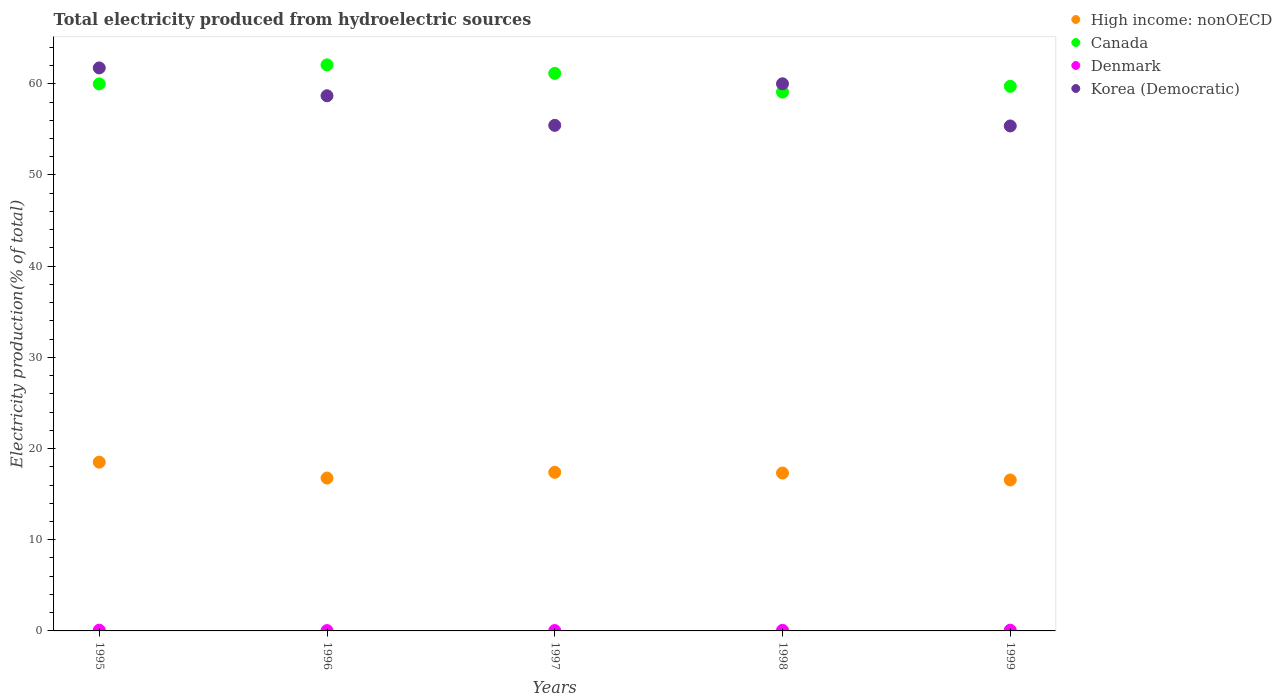Is the number of dotlines equal to the number of legend labels?
Provide a short and direct response. Yes. What is the total electricity produced in High income: nonOECD in 1998?
Your response must be concise. 17.31. Across all years, what is the maximum total electricity produced in High income: nonOECD?
Ensure brevity in your answer.  18.5. Across all years, what is the minimum total electricity produced in Canada?
Ensure brevity in your answer.  59.09. In which year was the total electricity produced in Canada minimum?
Ensure brevity in your answer.  1998. What is the total total electricity produced in Canada in the graph?
Make the answer very short. 302.02. What is the difference between the total electricity produced in High income: nonOECD in 1995 and that in 1996?
Keep it short and to the point. 1.74. What is the difference between the total electricity produced in Denmark in 1998 and the total electricity produced in Korea (Democratic) in 1999?
Offer a terse response. -55.31. What is the average total electricity produced in Denmark per year?
Give a very brief answer. 0.06. In the year 1999, what is the difference between the total electricity produced in High income: nonOECD and total electricity produced in Denmark?
Provide a short and direct response. 16.47. What is the ratio of the total electricity produced in Korea (Democratic) in 1995 to that in 1996?
Offer a very short reply. 1.05. Is the total electricity produced in High income: nonOECD in 1995 less than that in 1998?
Your response must be concise. No. Is the difference between the total electricity produced in High income: nonOECD in 1997 and 1998 greater than the difference between the total electricity produced in Denmark in 1997 and 1998?
Your answer should be very brief. Yes. What is the difference between the highest and the second highest total electricity produced in Denmark?
Offer a terse response. 0. What is the difference between the highest and the lowest total electricity produced in Canada?
Your answer should be very brief. 2.98. Is the sum of the total electricity produced in High income: nonOECD in 1996 and 1998 greater than the maximum total electricity produced in Denmark across all years?
Provide a succinct answer. Yes. Is it the case that in every year, the sum of the total electricity produced in Korea (Democratic) and total electricity produced in High income: nonOECD  is greater than the total electricity produced in Canada?
Your answer should be very brief. Yes. How many dotlines are there?
Keep it short and to the point. 4. How many years are there in the graph?
Give a very brief answer. 5. Are the values on the major ticks of Y-axis written in scientific E-notation?
Offer a very short reply. No. Does the graph contain grids?
Provide a short and direct response. No. Where does the legend appear in the graph?
Your answer should be compact. Top right. How are the legend labels stacked?
Offer a terse response. Vertical. What is the title of the graph?
Your answer should be very brief. Total electricity produced from hydroelectric sources. Does "Kuwait" appear as one of the legend labels in the graph?
Provide a short and direct response. No. What is the label or title of the X-axis?
Provide a short and direct response. Years. What is the Electricity production(% of total) in High income: nonOECD in 1995?
Provide a succinct answer. 18.5. What is the Electricity production(% of total) of Canada in 1995?
Offer a terse response. 59.99. What is the Electricity production(% of total) of Denmark in 1995?
Keep it short and to the point. 0.08. What is the Electricity production(% of total) in Korea (Democratic) in 1995?
Your response must be concise. 61.74. What is the Electricity production(% of total) of High income: nonOECD in 1996?
Your answer should be very brief. 16.76. What is the Electricity production(% of total) in Canada in 1996?
Offer a very short reply. 62.08. What is the Electricity production(% of total) in Denmark in 1996?
Provide a short and direct response. 0.04. What is the Electricity production(% of total) of Korea (Democratic) in 1996?
Give a very brief answer. 58.69. What is the Electricity production(% of total) of High income: nonOECD in 1997?
Keep it short and to the point. 17.39. What is the Electricity production(% of total) of Canada in 1997?
Offer a terse response. 61.14. What is the Electricity production(% of total) in Denmark in 1997?
Provide a short and direct response. 0.04. What is the Electricity production(% of total) of Korea (Democratic) in 1997?
Provide a short and direct response. 55.44. What is the Electricity production(% of total) of High income: nonOECD in 1998?
Keep it short and to the point. 17.31. What is the Electricity production(% of total) of Canada in 1998?
Your response must be concise. 59.09. What is the Electricity production(% of total) of Denmark in 1998?
Give a very brief answer. 0.07. What is the Electricity production(% of total) in High income: nonOECD in 1999?
Make the answer very short. 16.55. What is the Electricity production(% of total) in Canada in 1999?
Your response must be concise. 59.72. What is the Electricity production(% of total) of Denmark in 1999?
Provide a short and direct response. 0.08. What is the Electricity production(% of total) in Korea (Democratic) in 1999?
Provide a short and direct response. 55.38. Across all years, what is the maximum Electricity production(% of total) in High income: nonOECD?
Keep it short and to the point. 18.5. Across all years, what is the maximum Electricity production(% of total) in Canada?
Keep it short and to the point. 62.08. Across all years, what is the maximum Electricity production(% of total) in Denmark?
Provide a short and direct response. 0.08. Across all years, what is the maximum Electricity production(% of total) in Korea (Democratic)?
Offer a terse response. 61.74. Across all years, what is the minimum Electricity production(% of total) in High income: nonOECD?
Give a very brief answer. 16.55. Across all years, what is the minimum Electricity production(% of total) in Canada?
Your response must be concise. 59.09. Across all years, what is the minimum Electricity production(% of total) of Denmark?
Keep it short and to the point. 0.04. Across all years, what is the minimum Electricity production(% of total) of Korea (Democratic)?
Keep it short and to the point. 55.38. What is the total Electricity production(% of total) of High income: nonOECD in the graph?
Ensure brevity in your answer.  86.53. What is the total Electricity production(% of total) of Canada in the graph?
Your answer should be compact. 302.02. What is the total Electricity production(% of total) in Denmark in the graph?
Offer a terse response. 0.31. What is the total Electricity production(% of total) of Korea (Democratic) in the graph?
Make the answer very short. 291.24. What is the difference between the Electricity production(% of total) in High income: nonOECD in 1995 and that in 1996?
Provide a short and direct response. 1.74. What is the difference between the Electricity production(% of total) of Canada in 1995 and that in 1996?
Provide a succinct answer. -2.09. What is the difference between the Electricity production(% of total) in Denmark in 1995 and that in 1996?
Your answer should be compact. 0.05. What is the difference between the Electricity production(% of total) of Korea (Democratic) in 1995 and that in 1996?
Ensure brevity in your answer.  3.05. What is the difference between the Electricity production(% of total) in High income: nonOECD in 1995 and that in 1997?
Provide a succinct answer. 1.11. What is the difference between the Electricity production(% of total) of Canada in 1995 and that in 1997?
Keep it short and to the point. -1.15. What is the difference between the Electricity production(% of total) of Denmark in 1995 and that in 1997?
Keep it short and to the point. 0.04. What is the difference between the Electricity production(% of total) of Korea (Democratic) in 1995 and that in 1997?
Keep it short and to the point. 6.3. What is the difference between the Electricity production(% of total) of High income: nonOECD in 1995 and that in 1998?
Provide a succinct answer. 1.19. What is the difference between the Electricity production(% of total) in Canada in 1995 and that in 1998?
Ensure brevity in your answer.  0.89. What is the difference between the Electricity production(% of total) in Denmark in 1995 and that in 1998?
Your answer should be very brief. 0.02. What is the difference between the Electricity production(% of total) in Korea (Democratic) in 1995 and that in 1998?
Your response must be concise. 1.74. What is the difference between the Electricity production(% of total) in High income: nonOECD in 1995 and that in 1999?
Make the answer very short. 1.95. What is the difference between the Electricity production(% of total) of Canada in 1995 and that in 1999?
Provide a short and direct response. 0.26. What is the difference between the Electricity production(% of total) of Denmark in 1995 and that in 1999?
Make the answer very short. 0. What is the difference between the Electricity production(% of total) of Korea (Democratic) in 1995 and that in 1999?
Provide a succinct answer. 6.36. What is the difference between the Electricity production(% of total) of High income: nonOECD in 1996 and that in 1997?
Make the answer very short. -0.63. What is the difference between the Electricity production(% of total) of Canada in 1996 and that in 1997?
Your answer should be very brief. 0.94. What is the difference between the Electricity production(% of total) in Denmark in 1996 and that in 1997?
Ensure brevity in your answer.  -0.01. What is the difference between the Electricity production(% of total) in Korea (Democratic) in 1996 and that in 1997?
Your answer should be compact. 3.25. What is the difference between the Electricity production(% of total) in High income: nonOECD in 1996 and that in 1998?
Offer a terse response. -0.55. What is the difference between the Electricity production(% of total) in Canada in 1996 and that in 1998?
Give a very brief answer. 2.98. What is the difference between the Electricity production(% of total) of Denmark in 1996 and that in 1998?
Make the answer very short. -0.03. What is the difference between the Electricity production(% of total) in Korea (Democratic) in 1996 and that in 1998?
Give a very brief answer. -1.31. What is the difference between the Electricity production(% of total) in High income: nonOECD in 1996 and that in 1999?
Ensure brevity in your answer.  0.21. What is the difference between the Electricity production(% of total) of Canada in 1996 and that in 1999?
Your response must be concise. 2.35. What is the difference between the Electricity production(% of total) in Denmark in 1996 and that in 1999?
Keep it short and to the point. -0.04. What is the difference between the Electricity production(% of total) of Korea (Democratic) in 1996 and that in 1999?
Your answer should be compact. 3.31. What is the difference between the Electricity production(% of total) of High income: nonOECD in 1997 and that in 1998?
Provide a short and direct response. 0.08. What is the difference between the Electricity production(% of total) of Canada in 1997 and that in 1998?
Provide a succinct answer. 2.05. What is the difference between the Electricity production(% of total) of Denmark in 1997 and that in 1998?
Make the answer very short. -0.02. What is the difference between the Electricity production(% of total) of Korea (Democratic) in 1997 and that in 1998?
Provide a short and direct response. -4.56. What is the difference between the Electricity production(% of total) of High income: nonOECD in 1997 and that in 1999?
Keep it short and to the point. 0.84. What is the difference between the Electricity production(% of total) in Canada in 1997 and that in 1999?
Keep it short and to the point. 1.42. What is the difference between the Electricity production(% of total) of Denmark in 1997 and that in 1999?
Provide a short and direct response. -0.04. What is the difference between the Electricity production(% of total) in Korea (Democratic) in 1997 and that in 1999?
Your answer should be compact. 0.06. What is the difference between the Electricity production(% of total) in High income: nonOECD in 1998 and that in 1999?
Make the answer very short. 0.76. What is the difference between the Electricity production(% of total) of Canada in 1998 and that in 1999?
Keep it short and to the point. -0.63. What is the difference between the Electricity production(% of total) in Denmark in 1998 and that in 1999?
Provide a succinct answer. -0.01. What is the difference between the Electricity production(% of total) in Korea (Democratic) in 1998 and that in 1999?
Make the answer very short. 4.62. What is the difference between the Electricity production(% of total) of High income: nonOECD in 1995 and the Electricity production(% of total) of Canada in 1996?
Your answer should be very brief. -43.57. What is the difference between the Electricity production(% of total) of High income: nonOECD in 1995 and the Electricity production(% of total) of Denmark in 1996?
Keep it short and to the point. 18.47. What is the difference between the Electricity production(% of total) in High income: nonOECD in 1995 and the Electricity production(% of total) in Korea (Democratic) in 1996?
Your answer should be very brief. -40.18. What is the difference between the Electricity production(% of total) of Canada in 1995 and the Electricity production(% of total) of Denmark in 1996?
Provide a succinct answer. 59.95. What is the difference between the Electricity production(% of total) of Canada in 1995 and the Electricity production(% of total) of Korea (Democratic) in 1996?
Your answer should be very brief. 1.3. What is the difference between the Electricity production(% of total) in Denmark in 1995 and the Electricity production(% of total) in Korea (Democratic) in 1996?
Your response must be concise. -58.6. What is the difference between the Electricity production(% of total) in High income: nonOECD in 1995 and the Electricity production(% of total) in Canada in 1997?
Your response must be concise. -42.64. What is the difference between the Electricity production(% of total) in High income: nonOECD in 1995 and the Electricity production(% of total) in Denmark in 1997?
Give a very brief answer. 18.46. What is the difference between the Electricity production(% of total) in High income: nonOECD in 1995 and the Electricity production(% of total) in Korea (Democratic) in 1997?
Your response must be concise. -36.94. What is the difference between the Electricity production(% of total) of Canada in 1995 and the Electricity production(% of total) of Denmark in 1997?
Ensure brevity in your answer.  59.94. What is the difference between the Electricity production(% of total) in Canada in 1995 and the Electricity production(% of total) in Korea (Democratic) in 1997?
Your response must be concise. 4.55. What is the difference between the Electricity production(% of total) in Denmark in 1995 and the Electricity production(% of total) in Korea (Democratic) in 1997?
Offer a very short reply. -55.36. What is the difference between the Electricity production(% of total) in High income: nonOECD in 1995 and the Electricity production(% of total) in Canada in 1998?
Offer a terse response. -40.59. What is the difference between the Electricity production(% of total) of High income: nonOECD in 1995 and the Electricity production(% of total) of Denmark in 1998?
Offer a very short reply. 18.44. What is the difference between the Electricity production(% of total) in High income: nonOECD in 1995 and the Electricity production(% of total) in Korea (Democratic) in 1998?
Ensure brevity in your answer.  -41.5. What is the difference between the Electricity production(% of total) in Canada in 1995 and the Electricity production(% of total) in Denmark in 1998?
Offer a terse response. 59.92. What is the difference between the Electricity production(% of total) of Canada in 1995 and the Electricity production(% of total) of Korea (Democratic) in 1998?
Your response must be concise. -0.01. What is the difference between the Electricity production(% of total) of Denmark in 1995 and the Electricity production(% of total) of Korea (Democratic) in 1998?
Ensure brevity in your answer.  -59.92. What is the difference between the Electricity production(% of total) in High income: nonOECD in 1995 and the Electricity production(% of total) in Canada in 1999?
Keep it short and to the point. -41.22. What is the difference between the Electricity production(% of total) of High income: nonOECD in 1995 and the Electricity production(% of total) of Denmark in 1999?
Offer a terse response. 18.42. What is the difference between the Electricity production(% of total) in High income: nonOECD in 1995 and the Electricity production(% of total) in Korea (Democratic) in 1999?
Offer a terse response. -36.87. What is the difference between the Electricity production(% of total) in Canada in 1995 and the Electricity production(% of total) in Denmark in 1999?
Keep it short and to the point. 59.91. What is the difference between the Electricity production(% of total) in Canada in 1995 and the Electricity production(% of total) in Korea (Democratic) in 1999?
Offer a very short reply. 4.61. What is the difference between the Electricity production(% of total) in Denmark in 1995 and the Electricity production(% of total) in Korea (Democratic) in 1999?
Your answer should be compact. -55.29. What is the difference between the Electricity production(% of total) of High income: nonOECD in 1996 and the Electricity production(% of total) of Canada in 1997?
Ensure brevity in your answer.  -44.38. What is the difference between the Electricity production(% of total) of High income: nonOECD in 1996 and the Electricity production(% of total) of Denmark in 1997?
Offer a terse response. 16.72. What is the difference between the Electricity production(% of total) of High income: nonOECD in 1996 and the Electricity production(% of total) of Korea (Democratic) in 1997?
Give a very brief answer. -38.68. What is the difference between the Electricity production(% of total) in Canada in 1996 and the Electricity production(% of total) in Denmark in 1997?
Offer a terse response. 62.03. What is the difference between the Electricity production(% of total) in Canada in 1996 and the Electricity production(% of total) in Korea (Democratic) in 1997?
Your response must be concise. 6.63. What is the difference between the Electricity production(% of total) of Denmark in 1996 and the Electricity production(% of total) of Korea (Democratic) in 1997?
Offer a very short reply. -55.41. What is the difference between the Electricity production(% of total) in High income: nonOECD in 1996 and the Electricity production(% of total) in Canada in 1998?
Your answer should be very brief. -42.33. What is the difference between the Electricity production(% of total) in High income: nonOECD in 1996 and the Electricity production(% of total) in Denmark in 1998?
Give a very brief answer. 16.7. What is the difference between the Electricity production(% of total) in High income: nonOECD in 1996 and the Electricity production(% of total) in Korea (Democratic) in 1998?
Ensure brevity in your answer.  -43.24. What is the difference between the Electricity production(% of total) of Canada in 1996 and the Electricity production(% of total) of Denmark in 1998?
Your response must be concise. 62.01. What is the difference between the Electricity production(% of total) in Canada in 1996 and the Electricity production(% of total) in Korea (Democratic) in 1998?
Your answer should be compact. 2.08. What is the difference between the Electricity production(% of total) of Denmark in 1996 and the Electricity production(% of total) of Korea (Democratic) in 1998?
Provide a short and direct response. -59.96. What is the difference between the Electricity production(% of total) in High income: nonOECD in 1996 and the Electricity production(% of total) in Canada in 1999?
Make the answer very short. -42.96. What is the difference between the Electricity production(% of total) in High income: nonOECD in 1996 and the Electricity production(% of total) in Denmark in 1999?
Offer a very short reply. 16.68. What is the difference between the Electricity production(% of total) of High income: nonOECD in 1996 and the Electricity production(% of total) of Korea (Democratic) in 1999?
Make the answer very short. -38.61. What is the difference between the Electricity production(% of total) in Canada in 1996 and the Electricity production(% of total) in Denmark in 1999?
Your response must be concise. 62. What is the difference between the Electricity production(% of total) of Canada in 1996 and the Electricity production(% of total) of Korea (Democratic) in 1999?
Offer a very short reply. 6.7. What is the difference between the Electricity production(% of total) of Denmark in 1996 and the Electricity production(% of total) of Korea (Democratic) in 1999?
Offer a very short reply. -55.34. What is the difference between the Electricity production(% of total) in High income: nonOECD in 1997 and the Electricity production(% of total) in Canada in 1998?
Give a very brief answer. -41.7. What is the difference between the Electricity production(% of total) in High income: nonOECD in 1997 and the Electricity production(% of total) in Denmark in 1998?
Keep it short and to the point. 17.33. What is the difference between the Electricity production(% of total) of High income: nonOECD in 1997 and the Electricity production(% of total) of Korea (Democratic) in 1998?
Keep it short and to the point. -42.61. What is the difference between the Electricity production(% of total) of Canada in 1997 and the Electricity production(% of total) of Denmark in 1998?
Make the answer very short. 61.07. What is the difference between the Electricity production(% of total) of Canada in 1997 and the Electricity production(% of total) of Korea (Democratic) in 1998?
Give a very brief answer. 1.14. What is the difference between the Electricity production(% of total) in Denmark in 1997 and the Electricity production(% of total) in Korea (Democratic) in 1998?
Ensure brevity in your answer.  -59.96. What is the difference between the Electricity production(% of total) in High income: nonOECD in 1997 and the Electricity production(% of total) in Canada in 1999?
Your answer should be compact. -42.33. What is the difference between the Electricity production(% of total) in High income: nonOECD in 1997 and the Electricity production(% of total) in Denmark in 1999?
Offer a terse response. 17.31. What is the difference between the Electricity production(% of total) in High income: nonOECD in 1997 and the Electricity production(% of total) in Korea (Democratic) in 1999?
Make the answer very short. -37.98. What is the difference between the Electricity production(% of total) in Canada in 1997 and the Electricity production(% of total) in Denmark in 1999?
Your response must be concise. 61.06. What is the difference between the Electricity production(% of total) of Canada in 1997 and the Electricity production(% of total) of Korea (Democratic) in 1999?
Provide a short and direct response. 5.76. What is the difference between the Electricity production(% of total) of Denmark in 1997 and the Electricity production(% of total) of Korea (Democratic) in 1999?
Give a very brief answer. -55.33. What is the difference between the Electricity production(% of total) of High income: nonOECD in 1998 and the Electricity production(% of total) of Canada in 1999?
Keep it short and to the point. -42.41. What is the difference between the Electricity production(% of total) in High income: nonOECD in 1998 and the Electricity production(% of total) in Denmark in 1999?
Your answer should be very brief. 17.23. What is the difference between the Electricity production(% of total) in High income: nonOECD in 1998 and the Electricity production(% of total) in Korea (Democratic) in 1999?
Give a very brief answer. -38.06. What is the difference between the Electricity production(% of total) of Canada in 1998 and the Electricity production(% of total) of Denmark in 1999?
Ensure brevity in your answer.  59.01. What is the difference between the Electricity production(% of total) in Canada in 1998 and the Electricity production(% of total) in Korea (Democratic) in 1999?
Offer a very short reply. 3.72. What is the difference between the Electricity production(% of total) in Denmark in 1998 and the Electricity production(% of total) in Korea (Democratic) in 1999?
Provide a short and direct response. -55.31. What is the average Electricity production(% of total) in High income: nonOECD per year?
Provide a succinct answer. 17.31. What is the average Electricity production(% of total) of Canada per year?
Keep it short and to the point. 60.4. What is the average Electricity production(% of total) of Denmark per year?
Offer a terse response. 0.06. What is the average Electricity production(% of total) in Korea (Democratic) per year?
Your response must be concise. 58.25. In the year 1995, what is the difference between the Electricity production(% of total) of High income: nonOECD and Electricity production(% of total) of Canada?
Offer a terse response. -41.48. In the year 1995, what is the difference between the Electricity production(% of total) of High income: nonOECD and Electricity production(% of total) of Denmark?
Give a very brief answer. 18.42. In the year 1995, what is the difference between the Electricity production(% of total) in High income: nonOECD and Electricity production(% of total) in Korea (Democratic)?
Offer a terse response. -43.24. In the year 1995, what is the difference between the Electricity production(% of total) of Canada and Electricity production(% of total) of Denmark?
Ensure brevity in your answer.  59.9. In the year 1995, what is the difference between the Electricity production(% of total) in Canada and Electricity production(% of total) in Korea (Democratic)?
Your answer should be very brief. -1.75. In the year 1995, what is the difference between the Electricity production(% of total) in Denmark and Electricity production(% of total) in Korea (Democratic)?
Your response must be concise. -61.66. In the year 1996, what is the difference between the Electricity production(% of total) in High income: nonOECD and Electricity production(% of total) in Canada?
Your answer should be very brief. -45.31. In the year 1996, what is the difference between the Electricity production(% of total) in High income: nonOECD and Electricity production(% of total) in Denmark?
Provide a succinct answer. 16.73. In the year 1996, what is the difference between the Electricity production(% of total) in High income: nonOECD and Electricity production(% of total) in Korea (Democratic)?
Keep it short and to the point. -41.92. In the year 1996, what is the difference between the Electricity production(% of total) in Canada and Electricity production(% of total) in Denmark?
Offer a terse response. 62.04. In the year 1996, what is the difference between the Electricity production(% of total) of Canada and Electricity production(% of total) of Korea (Democratic)?
Your answer should be compact. 3.39. In the year 1996, what is the difference between the Electricity production(% of total) in Denmark and Electricity production(% of total) in Korea (Democratic)?
Your answer should be very brief. -58.65. In the year 1997, what is the difference between the Electricity production(% of total) of High income: nonOECD and Electricity production(% of total) of Canada?
Provide a succinct answer. -43.75. In the year 1997, what is the difference between the Electricity production(% of total) of High income: nonOECD and Electricity production(% of total) of Denmark?
Provide a succinct answer. 17.35. In the year 1997, what is the difference between the Electricity production(% of total) in High income: nonOECD and Electricity production(% of total) in Korea (Democratic)?
Ensure brevity in your answer.  -38.05. In the year 1997, what is the difference between the Electricity production(% of total) in Canada and Electricity production(% of total) in Denmark?
Keep it short and to the point. 61.1. In the year 1997, what is the difference between the Electricity production(% of total) in Canada and Electricity production(% of total) in Korea (Democratic)?
Provide a short and direct response. 5.7. In the year 1997, what is the difference between the Electricity production(% of total) in Denmark and Electricity production(% of total) in Korea (Democratic)?
Your answer should be very brief. -55.4. In the year 1998, what is the difference between the Electricity production(% of total) in High income: nonOECD and Electricity production(% of total) in Canada?
Your answer should be compact. -41.78. In the year 1998, what is the difference between the Electricity production(% of total) of High income: nonOECD and Electricity production(% of total) of Denmark?
Keep it short and to the point. 17.25. In the year 1998, what is the difference between the Electricity production(% of total) of High income: nonOECD and Electricity production(% of total) of Korea (Democratic)?
Your response must be concise. -42.69. In the year 1998, what is the difference between the Electricity production(% of total) of Canada and Electricity production(% of total) of Denmark?
Offer a terse response. 59.03. In the year 1998, what is the difference between the Electricity production(% of total) of Canada and Electricity production(% of total) of Korea (Democratic)?
Your answer should be very brief. -0.91. In the year 1998, what is the difference between the Electricity production(% of total) of Denmark and Electricity production(% of total) of Korea (Democratic)?
Offer a terse response. -59.93. In the year 1999, what is the difference between the Electricity production(% of total) of High income: nonOECD and Electricity production(% of total) of Canada?
Offer a terse response. -43.17. In the year 1999, what is the difference between the Electricity production(% of total) in High income: nonOECD and Electricity production(% of total) in Denmark?
Provide a short and direct response. 16.47. In the year 1999, what is the difference between the Electricity production(% of total) of High income: nonOECD and Electricity production(% of total) of Korea (Democratic)?
Offer a very short reply. -38.82. In the year 1999, what is the difference between the Electricity production(% of total) of Canada and Electricity production(% of total) of Denmark?
Ensure brevity in your answer.  59.64. In the year 1999, what is the difference between the Electricity production(% of total) in Canada and Electricity production(% of total) in Korea (Democratic)?
Give a very brief answer. 4.35. In the year 1999, what is the difference between the Electricity production(% of total) in Denmark and Electricity production(% of total) in Korea (Democratic)?
Offer a terse response. -55.3. What is the ratio of the Electricity production(% of total) in High income: nonOECD in 1995 to that in 1996?
Your answer should be compact. 1.1. What is the ratio of the Electricity production(% of total) in Canada in 1995 to that in 1996?
Offer a very short reply. 0.97. What is the ratio of the Electricity production(% of total) of Denmark in 1995 to that in 1996?
Give a very brief answer. 2.3. What is the ratio of the Electricity production(% of total) of Korea (Democratic) in 1995 to that in 1996?
Keep it short and to the point. 1.05. What is the ratio of the Electricity production(% of total) in High income: nonOECD in 1995 to that in 1997?
Offer a terse response. 1.06. What is the ratio of the Electricity production(% of total) in Canada in 1995 to that in 1997?
Ensure brevity in your answer.  0.98. What is the ratio of the Electricity production(% of total) in Denmark in 1995 to that in 1997?
Keep it short and to the point. 1.9. What is the ratio of the Electricity production(% of total) of Korea (Democratic) in 1995 to that in 1997?
Provide a short and direct response. 1.11. What is the ratio of the Electricity production(% of total) in High income: nonOECD in 1995 to that in 1998?
Provide a short and direct response. 1.07. What is the ratio of the Electricity production(% of total) of Canada in 1995 to that in 1998?
Provide a short and direct response. 1.02. What is the ratio of the Electricity production(% of total) in Denmark in 1995 to that in 1998?
Your response must be concise. 1.24. What is the ratio of the Electricity production(% of total) of Korea (Democratic) in 1995 to that in 1998?
Keep it short and to the point. 1.03. What is the ratio of the Electricity production(% of total) in High income: nonOECD in 1995 to that in 1999?
Offer a terse response. 1.12. What is the ratio of the Electricity production(% of total) in Denmark in 1995 to that in 1999?
Your answer should be very brief. 1.02. What is the ratio of the Electricity production(% of total) of Korea (Democratic) in 1995 to that in 1999?
Provide a succinct answer. 1.11. What is the ratio of the Electricity production(% of total) of High income: nonOECD in 1996 to that in 1997?
Provide a short and direct response. 0.96. What is the ratio of the Electricity production(% of total) in Canada in 1996 to that in 1997?
Make the answer very short. 1.02. What is the ratio of the Electricity production(% of total) in Denmark in 1996 to that in 1997?
Your response must be concise. 0.83. What is the ratio of the Electricity production(% of total) in Korea (Democratic) in 1996 to that in 1997?
Keep it short and to the point. 1.06. What is the ratio of the Electricity production(% of total) in High income: nonOECD in 1996 to that in 1998?
Give a very brief answer. 0.97. What is the ratio of the Electricity production(% of total) of Canada in 1996 to that in 1998?
Offer a terse response. 1.05. What is the ratio of the Electricity production(% of total) in Denmark in 1996 to that in 1998?
Keep it short and to the point. 0.54. What is the ratio of the Electricity production(% of total) in Korea (Democratic) in 1996 to that in 1998?
Your answer should be very brief. 0.98. What is the ratio of the Electricity production(% of total) of High income: nonOECD in 1996 to that in 1999?
Give a very brief answer. 1.01. What is the ratio of the Electricity production(% of total) of Canada in 1996 to that in 1999?
Offer a terse response. 1.04. What is the ratio of the Electricity production(% of total) of Denmark in 1996 to that in 1999?
Ensure brevity in your answer.  0.45. What is the ratio of the Electricity production(% of total) in Korea (Democratic) in 1996 to that in 1999?
Your answer should be very brief. 1.06. What is the ratio of the Electricity production(% of total) of High income: nonOECD in 1997 to that in 1998?
Your response must be concise. 1. What is the ratio of the Electricity production(% of total) in Canada in 1997 to that in 1998?
Give a very brief answer. 1.03. What is the ratio of the Electricity production(% of total) of Denmark in 1997 to that in 1998?
Provide a short and direct response. 0.65. What is the ratio of the Electricity production(% of total) in Korea (Democratic) in 1997 to that in 1998?
Make the answer very short. 0.92. What is the ratio of the Electricity production(% of total) in High income: nonOECD in 1997 to that in 1999?
Keep it short and to the point. 1.05. What is the ratio of the Electricity production(% of total) of Canada in 1997 to that in 1999?
Offer a very short reply. 1.02. What is the ratio of the Electricity production(% of total) in Denmark in 1997 to that in 1999?
Offer a terse response. 0.54. What is the ratio of the Electricity production(% of total) of High income: nonOECD in 1998 to that in 1999?
Make the answer very short. 1.05. What is the ratio of the Electricity production(% of total) in Canada in 1998 to that in 1999?
Make the answer very short. 0.99. What is the ratio of the Electricity production(% of total) of Denmark in 1998 to that in 1999?
Make the answer very short. 0.82. What is the ratio of the Electricity production(% of total) in Korea (Democratic) in 1998 to that in 1999?
Ensure brevity in your answer.  1.08. What is the difference between the highest and the second highest Electricity production(% of total) in High income: nonOECD?
Give a very brief answer. 1.11. What is the difference between the highest and the second highest Electricity production(% of total) in Canada?
Offer a terse response. 0.94. What is the difference between the highest and the second highest Electricity production(% of total) of Denmark?
Your answer should be compact. 0. What is the difference between the highest and the second highest Electricity production(% of total) in Korea (Democratic)?
Ensure brevity in your answer.  1.74. What is the difference between the highest and the lowest Electricity production(% of total) of High income: nonOECD?
Provide a short and direct response. 1.95. What is the difference between the highest and the lowest Electricity production(% of total) in Canada?
Keep it short and to the point. 2.98. What is the difference between the highest and the lowest Electricity production(% of total) of Denmark?
Your response must be concise. 0.05. What is the difference between the highest and the lowest Electricity production(% of total) of Korea (Democratic)?
Offer a very short reply. 6.36. 